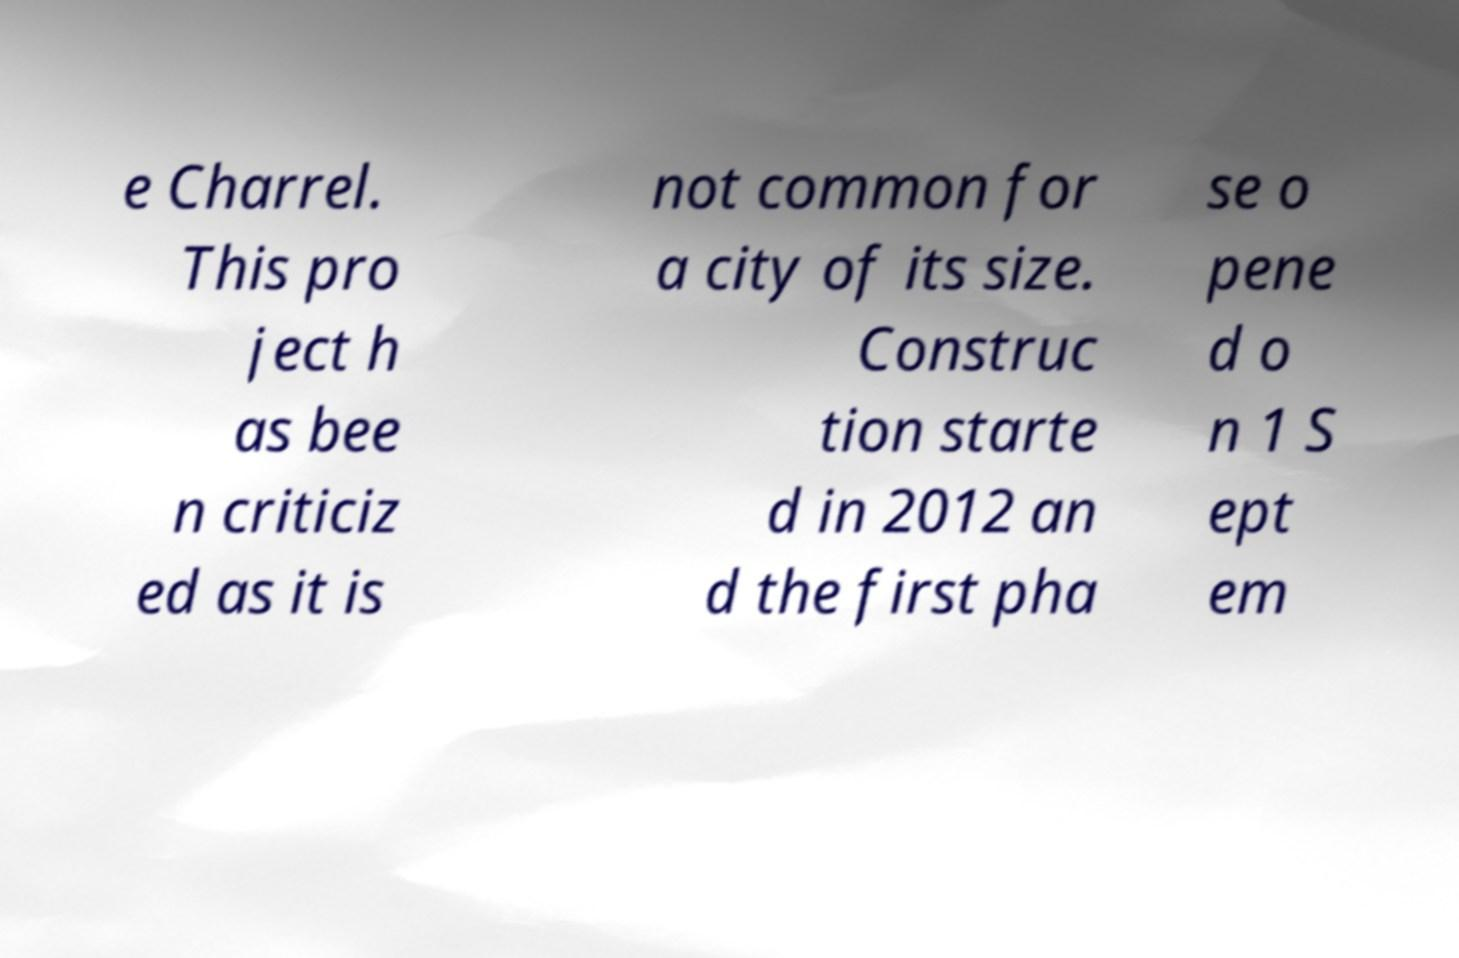For documentation purposes, I need the text within this image transcribed. Could you provide that? e Charrel. This pro ject h as bee n criticiz ed as it is not common for a city of its size. Construc tion starte d in 2012 an d the first pha se o pene d o n 1 S ept em 